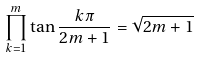Convert formula to latex. <formula><loc_0><loc_0><loc_500><loc_500>\prod _ { k = 1 } ^ { m } \tan { \frac { k \pi } { 2 m + 1 } } = { \sqrt { 2 m + 1 } }</formula> 